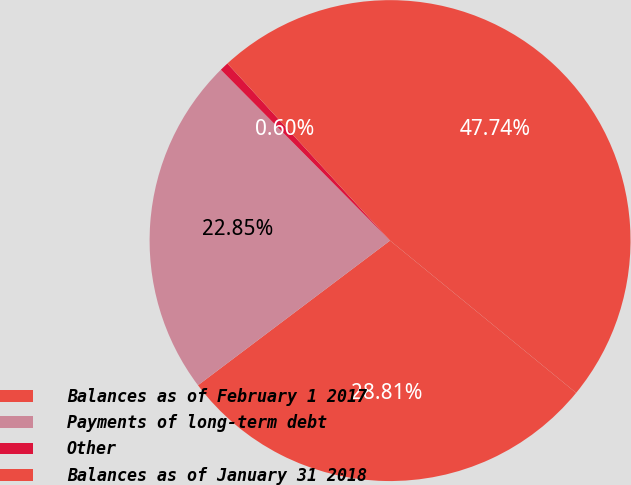<chart> <loc_0><loc_0><loc_500><loc_500><pie_chart><fcel>Balances as of February 1 2017<fcel>Payments of long-term debt<fcel>Other<fcel>Balances as of January 31 2018<nl><fcel>28.81%<fcel>22.85%<fcel>0.6%<fcel>47.74%<nl></chart> 